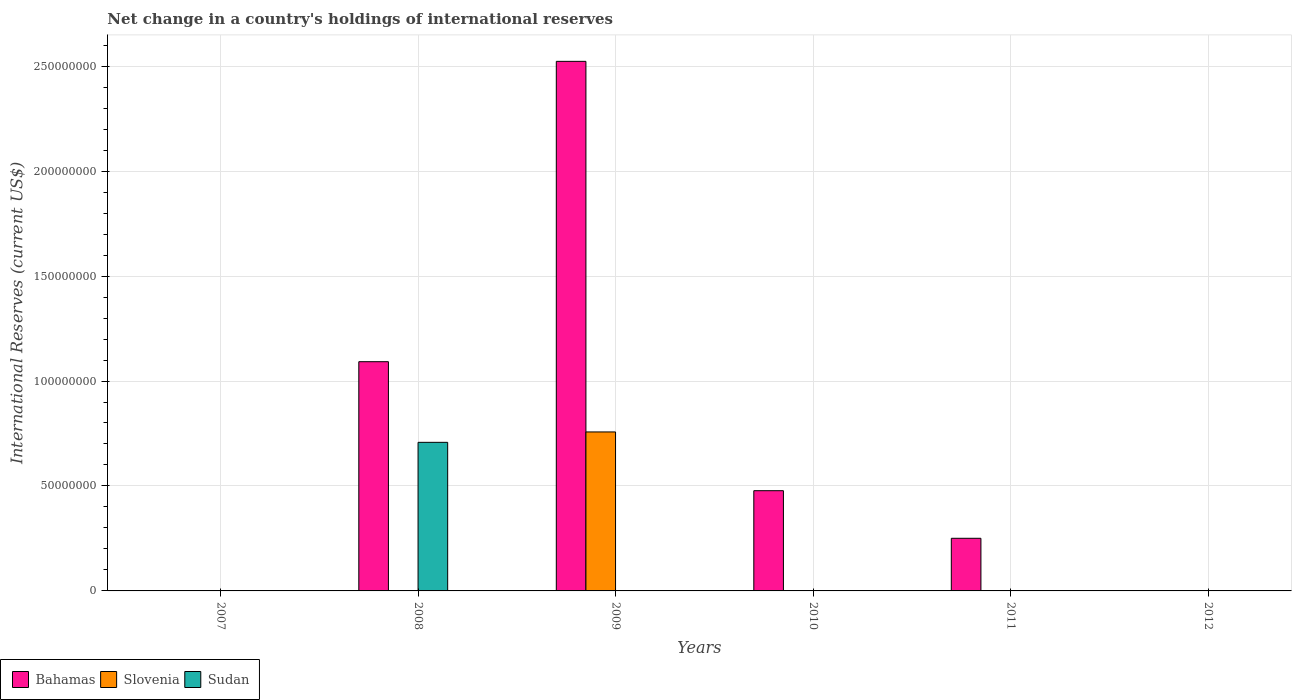How many different coloured bars are there?
Give a very brief answer. 3. Are the number of bars per tick equal to the number of legend labels?
Offer a very short reply. No. How many bars are there on the 3rd tick from the right?
Offer a terse response. 1. What is the label of the 2nd group of bars from the left?
Offer a terse response. 2008. What is the international reserves in Bahamas in 2008?
Offer a terse response. 1.09e+08. Across all years, what is the maximum international reserves in Bahamas?
Ensure brevity in your answer.  2.52e+08. In which year was the international reserves in Slovenia maximum?
Keep it short and to the point. 2009. What is the total international reserves in Slovenia in the graph?
Ensure brevity in your answer.  7.57e+07. What is the difference between the international reserves in Bahamas in 2011 and the international reserves in Sudan in 2009?
Offer a very short reply. 2.51e+07. What is the average international reserves in Bahamas per year?
Keep it short and to the point. 7.24e+07. What is the ratio of the international reserves in Bahamas in 2008 to that in 2011?
Provide a succinct answer. 4.36. Is the international reserves in Bahamas in 2008 less than that in 2011?
Offer a very short reply. No. What is the difference between the highest and the second highest international reserves in Bahamas?
Provide a short and direct response. 1.43e+08. What is the difference between the highest and the lowest international reserves in Bahamas?
Your answer should be very brief. 2.52e+08. In how many years, is the international reserves in Sudan greater than the average international reserves in Sudan taken over all years?
Offer a terse response. 1. Is the sum of the international reserves in Bahamas in 2009 and 2011 greater than the maximum international reserves in Slovenia across all years?
Offer a terse response. Yes. Is it the case that in every year, the sum of the international reserves in Sudan and international reserves in Slovenia is greater than the international reserves in Bahamas?
Offer a terse response. No. How many bars are there?
Keep it short and to the point. 6. How many years are there in the graph?
Offer a terse response. 6. What is the difference between two consecutive major ticks on the Y-axis?
Offer a very short reply. 5.00e+07. Does the graph contain grids?
Provide a short and direct response. Yes. Where does the legend appear in the graph?
Give a very brief answer. Bottom left. How many legend labels are there?
Make the answer very short. 3. How are the legend labels stacked?
Give a very brief answer. Horizontal. What is the title of the graph?
Your answer should be very brief. Net change in a country's holdings of international reserves. What is the label or title of the Y-axis?
Provide a short and direct response. International Reserves (current US$). What is the International Reserves (current US$) in Bahamas in 2007?
Your response must be concise. 0. What is the International Reserves (current US$) of Slovenia in 2007?
Your answer should be compact. 0. What is the International Reserves (current US$) of Bahamas in 2008?
Make the answer very short. 1.09e+08. What is the International Reserves (current US$) of Sudan in 2008?
Your answer should be very brief. 7.08e+07. What is the International Reserves (current US$) in Bahamas in 2009?
Offer a very short reply. 2.52e+08. What is the International Reserves (current US$) in Slovenia in 2009?
Your response must be concise. 7.57e+07. What is the International Reserves (current US$) in Sudan in 2009?
Make the answer very short. 0. What is the International Reserves (current US$) of Bahamas in 2010?
Your answer should be compact. 4.78e+07. What is the International Reserves (current US$) of Bahamas in 2011?
Offer a terse response. 2.51e+07. What is the International Reserves (current US$) in Slovenia in 2011?
Ensure brevity in your answer.  0. What is the International Reserves (current US$) of Sudan in 2011?
Offer a very short reply. 0. What is the International Reserves (current US$) in Bahamas in 2012?
Ensure brevity in your answer.  0. What is the International Reserves (current US$) of Slovenia in 2012?
Your answer should be very brief. 0. Across all years, what is the maximum International Reserves (current US$) in Bahamas?
Offer a terse response. 2.52e+08. Across all years, what is the maximum International Reserves (current US$) in Slovenia?
Offer a very short reply. 7.57e+07. Across all years, what is the maximum International Reserves (current US$) in Sudan?
Provide a short and direct response. 7.08e+07. Across all years, what is the minimum International Reserves (current US$) of Bahamas?
Keep it short and to the point. 0. Across all years, what is the minimum International Reserves (current US$) in Slovenia?
Provide a succinct answer. 0. What is the total International Reserves (current US$) of Bahamas in the graph?
Give a very brief answer. 4.34e+08. What is the total International Reserves (current US$) in Slovenia in the graph?
Provide a succinct answer. 7.57e+07. What is the total International Reserves (current US$) in Sudan in the graph?
Provide a short and direct response. 7.08e+07. What is the difference between the International Reserves (current US$) of Bahamas in 2008 and that in 2009?
Give a very brief answer. -1.43e+08. What is the difference between the International Reserves (current US$) in Bahamas in 2008 and that in 2010?
Give a very brief answer. 6.15e+07. What is the difference between the International Reserves (current US$) of Bahamas in 2008 and that in 2011?
Your response must be concise. 8.41e+07. What is the difference between the International Reserves (current US$) in Bahamas in 2009 and that in 2010?
Keep it short and to the point. 2.05e+08. What is the difference between the International Reserves (current US$) of Bahamas in 2009 and that in 2011?
Your answer should be very brief. 2.27e+08. What is the difference between the International Reserves (current US$) of Bahamas in 2010 and that in 2011?
Your answer should be very brief. 2.27e+07. What is the difference between the International Reserves (current US$) of Bahamas in 2008 and the International Reserves (current US$) of Slovenia in 2009?
Provide a short and direct response. 3.35e+07. What is the average International Reserves (current US$) of Bahamas per year?
Your answer should be very brief. 7.24e+07. What is the average International Reserves (current US$) of Slovenia per year?
Offer a very short reply. 1.26e+07. What is the average International Reserves (current US$) of Sudan per year?
Keep it short and to the point. 1.18e+07. In the year 2008, what is the difference between the International Reserves (current US$) in Bahamas and International Reserves (current US$) in Sudan?
Provide a short and direct response. 3.84e+07. In the year 2009, what is the difference between the International Reserves (current US$) in Bahamas and International Reserves (current US$) in Slovenia?
Keep it short and to the point. 1.77e+08. What is the ratio of the International Reserves (current US$) of Bahamas in 2008 to that in 2009?
Keep it short and to the point. 0.43. What is the ratio of the International Reserves (current US$) in Bahamas in 2008 to that in 2010?
Ensure brevity in your answer.  2.29. What is the ratio of the International Reserves (current US$) of Bahamas in 2008 to that in 2011?
Give a very brief answer. 4.36. What is the ratio of the International Reserves (current US$) of Bahamas in 2009 to that in 2010?
Provide a succinct answer. 5.28. What is the ratio of the International Reserves (current US$) of Bahamas in 2009 to that in 2011?
Your response must be concise. 10.06. What is the ratio of the International Reserves (current US$) in Bahamas in 2010 to that in 2011?
Provide a short and direct response. 1.9. What is the difference between the highest and the second highest International Reserves (current US$) of Bahamas?
Ensure brevity in your answer.  1.43e+08. What is the difference between the highest and the lowest International Reserves (current US$) in Bahamas?
Ensure brevity in your answer.  2.52e+08. What is the difference between the highest and the lowest International Reserves (current US$) in Slovenia?
Offer a very short reply. 7.57e+07. What is the difference between the highest and the lowest International Reserves (current US$) of Sudan?
Provide a short and direct response. 7.08e+07. 